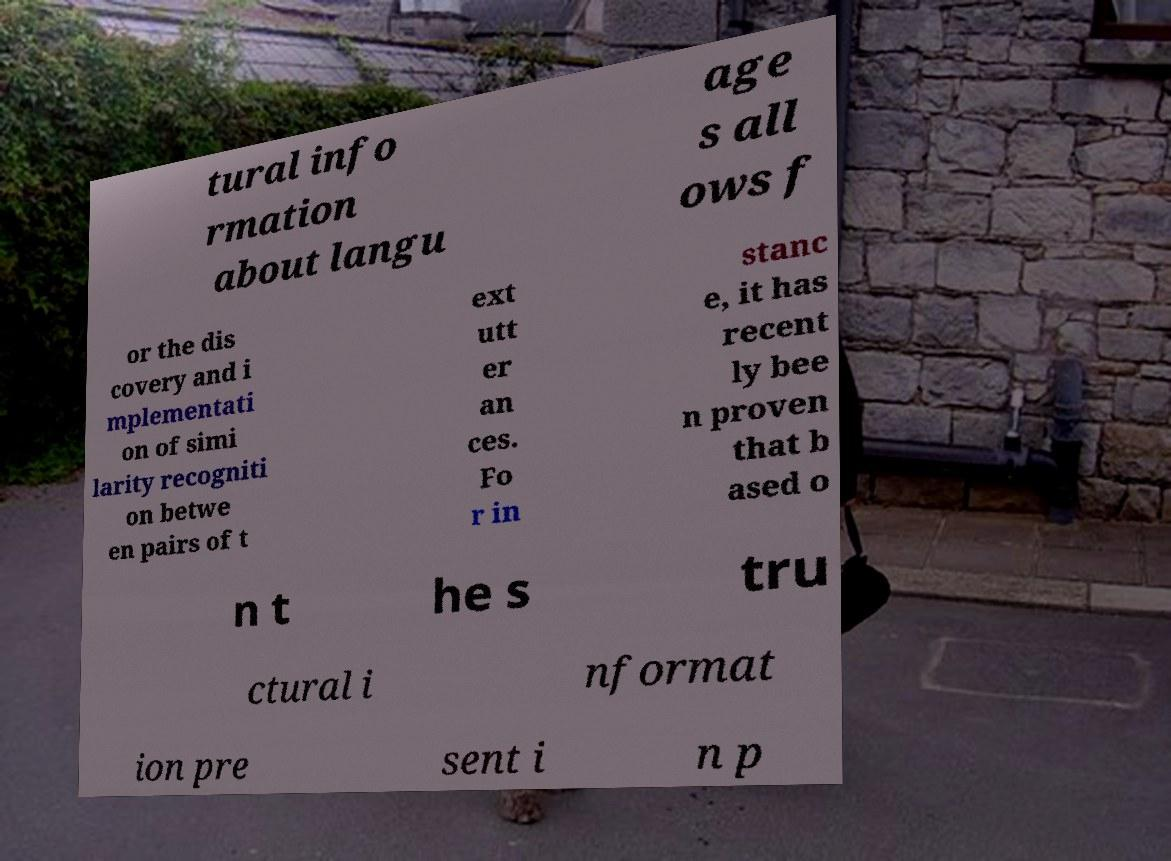Please read and relay the text visible in this image. What does it say? tural info rmation about langu age s all ows f or the dis covery and i mplementati on of simi larity recogniti on betwe en pairs of t ext utt er an ces. Fo r in stanc e, it has recent ly bee n proven that b ased o n t he s tru ctural i nformat ion pre sent i n p 